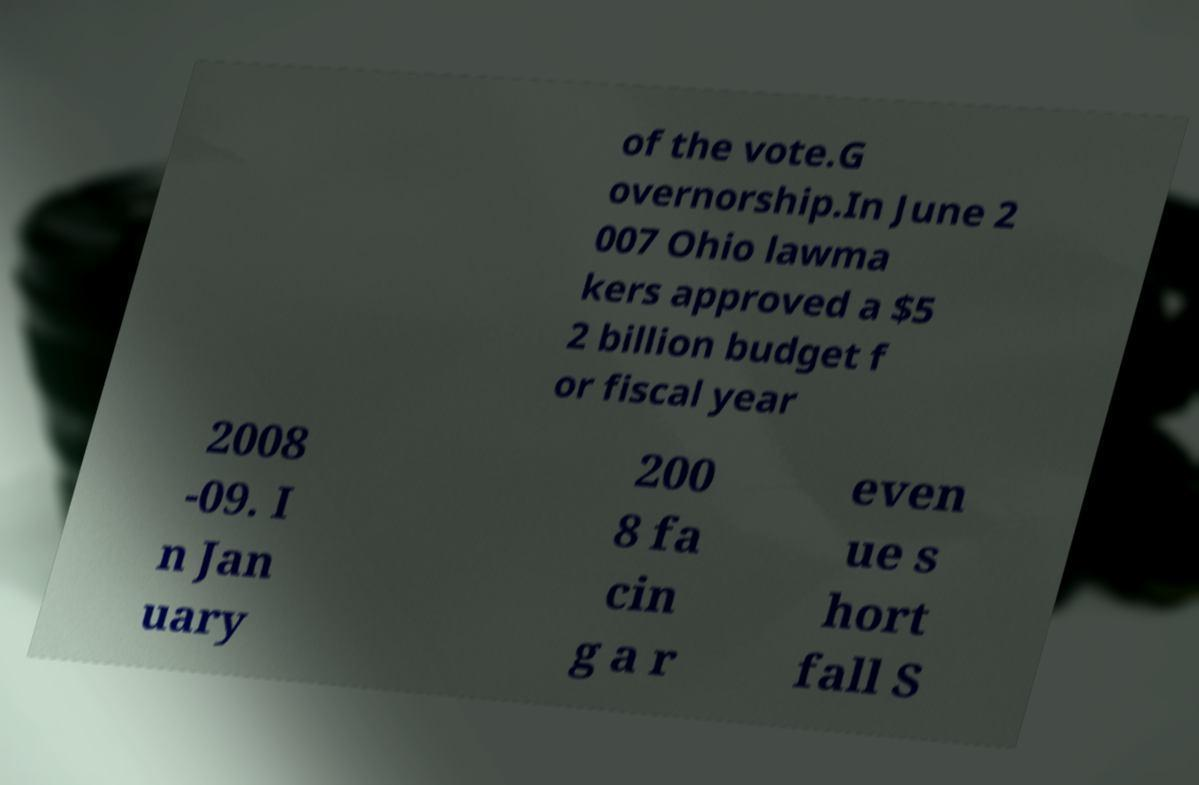There's text embedded in this image that I need extracted. Can you transcribe it verbatim? of the vote.G overnorship.In June 2 007 Ohio lawma kers approved a $5 2 billion budget f or fiscal year 2008 -09. I n Jan uary 200 8 fa cin g a r even ue s hort fall S 